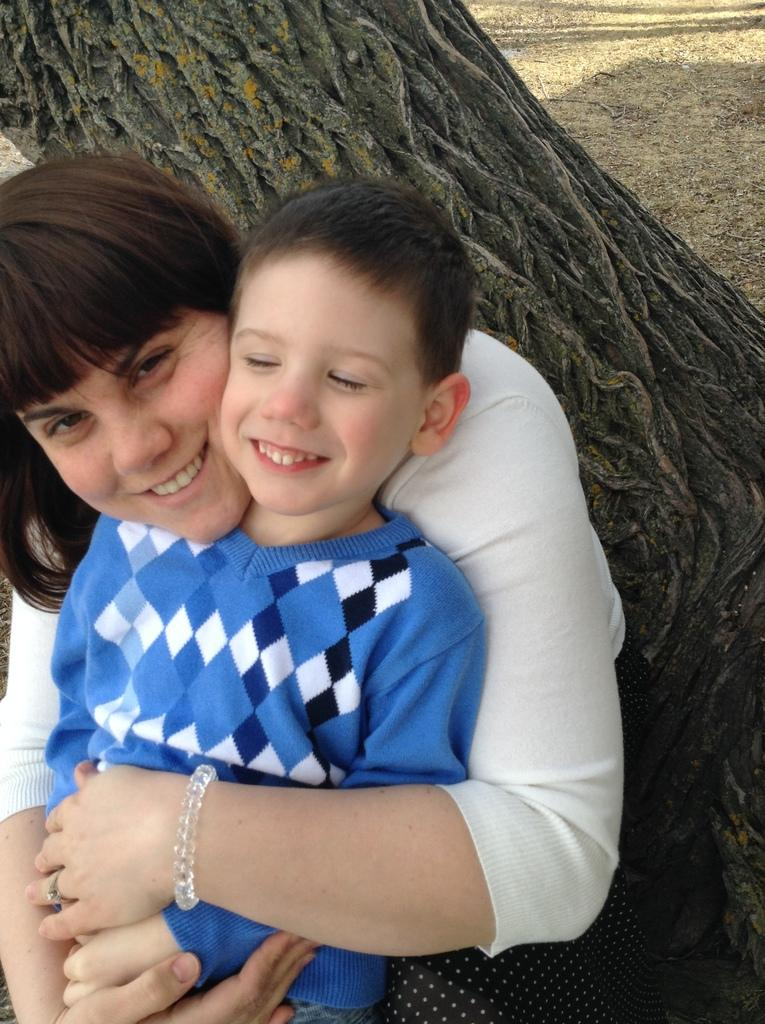Who are the people in the image? There is a woman and a boy in the image. What can be seen on the backside of the image? The bark of a tree is visible on the backside of the image. What type of guitar is the group playing in the image? There is no guitar or group present in the image; it features a woman and a boy. 